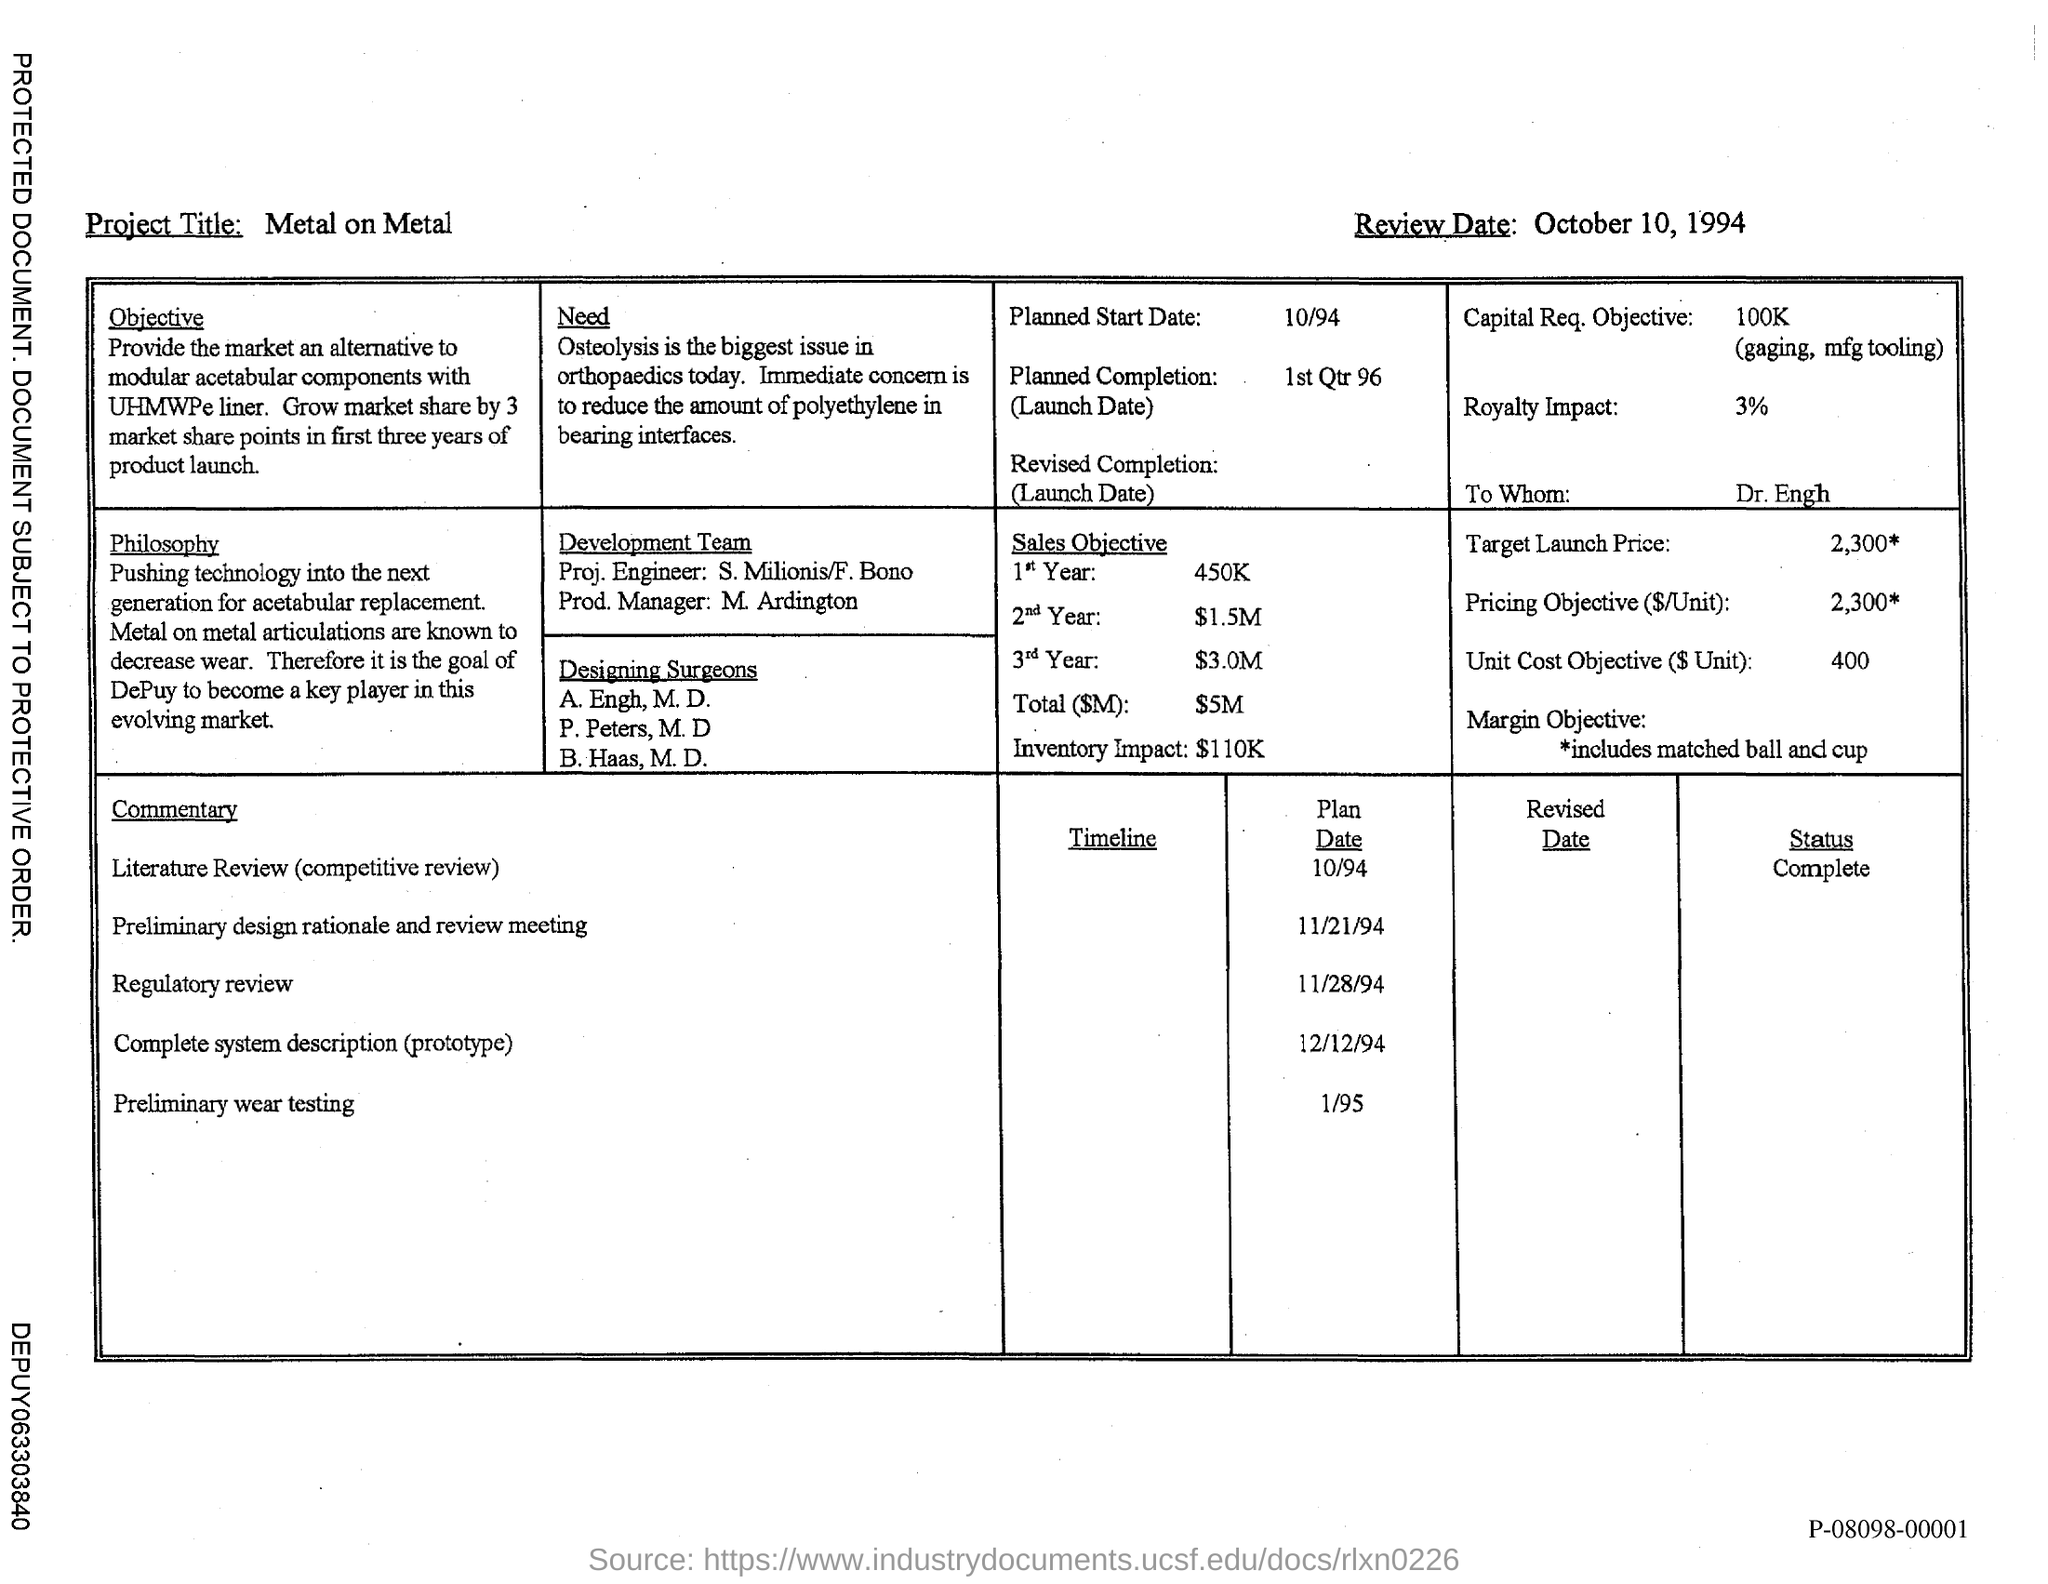What is the project title mentioned in this document?
Provide a short and direct response. Metal on Metal. What is the review date mentioned in this document?
Offer a terse response. October 10, 1994. 